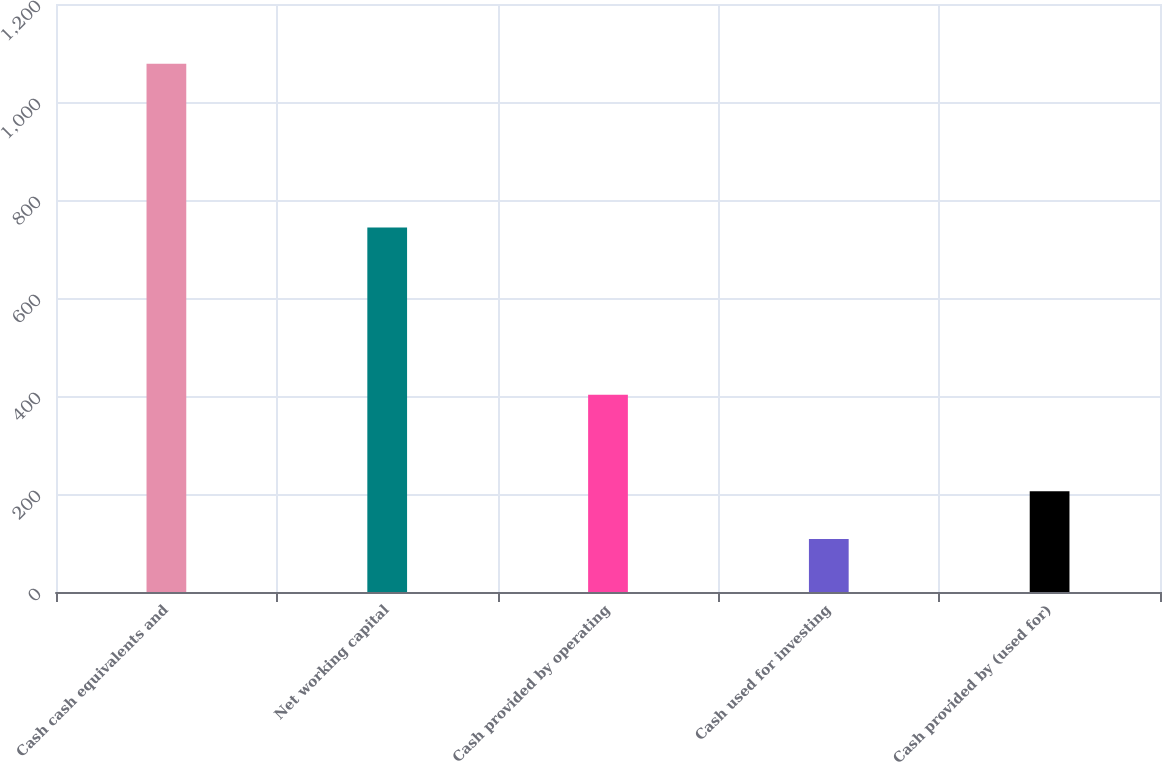Convert chart to OTSL. <chart><loc_0><loc_0><loc_500><loc_500><bar_chart><fcel>Cash cash equivalents and<fcel>Net working capital<fcel>Cash provided by operating<fcel>Cash used for investing<fcel>Cash provided by (used for)<nl><fcel>1078.1<fcel>744.1<fcel>402.4<fcel>108.4<fcel>205.37<nl></chart> 